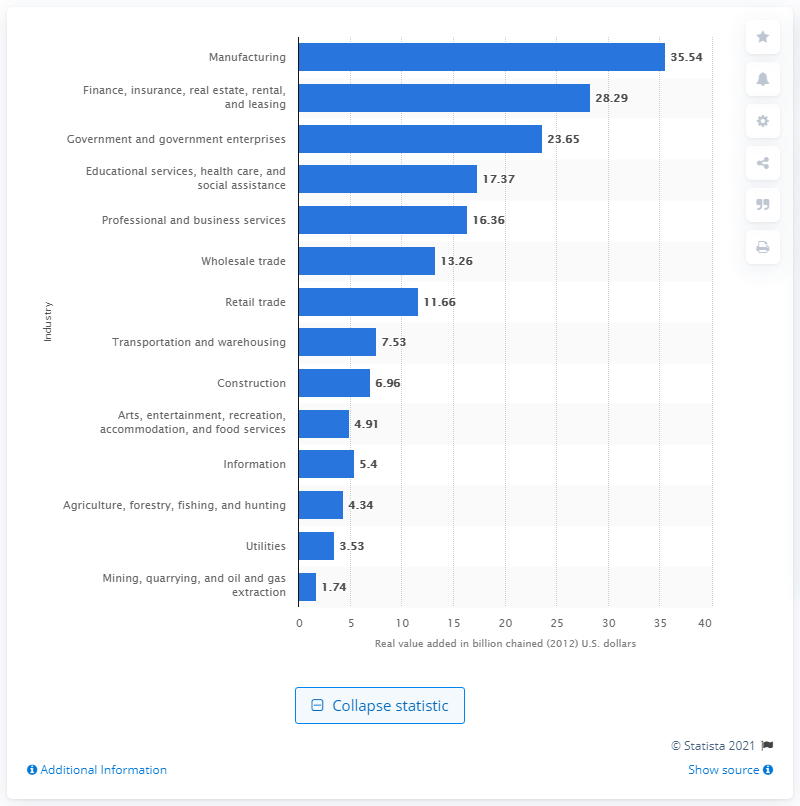Give some essential details in this illustration. In 2020, the manufacturing industry contributed a significant amount to Kentucky's Gross Domestic Product, with a value of 35.54. 